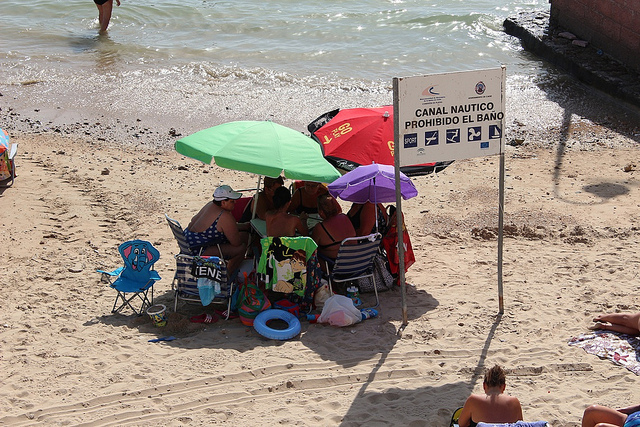<image>What kinds of activities are prohibited here? It is ambiguous what kinds of activities are prohibited here. Might be smoking, boating, skiing, swimming or surfing diving etc. What is the woman looking for in the gravel? I don't know what the woman is looking for in the gravel. It could be shells, sand, crabs, or nothing at all. What kinds of activities are prohibited here? I don't know what kinds of activities are prohibited here. It could be smoking, boating, skiing, swimming, or surfing diving. What is the woman looking for in the gravel? The woman is looking for shells in the gravel. 